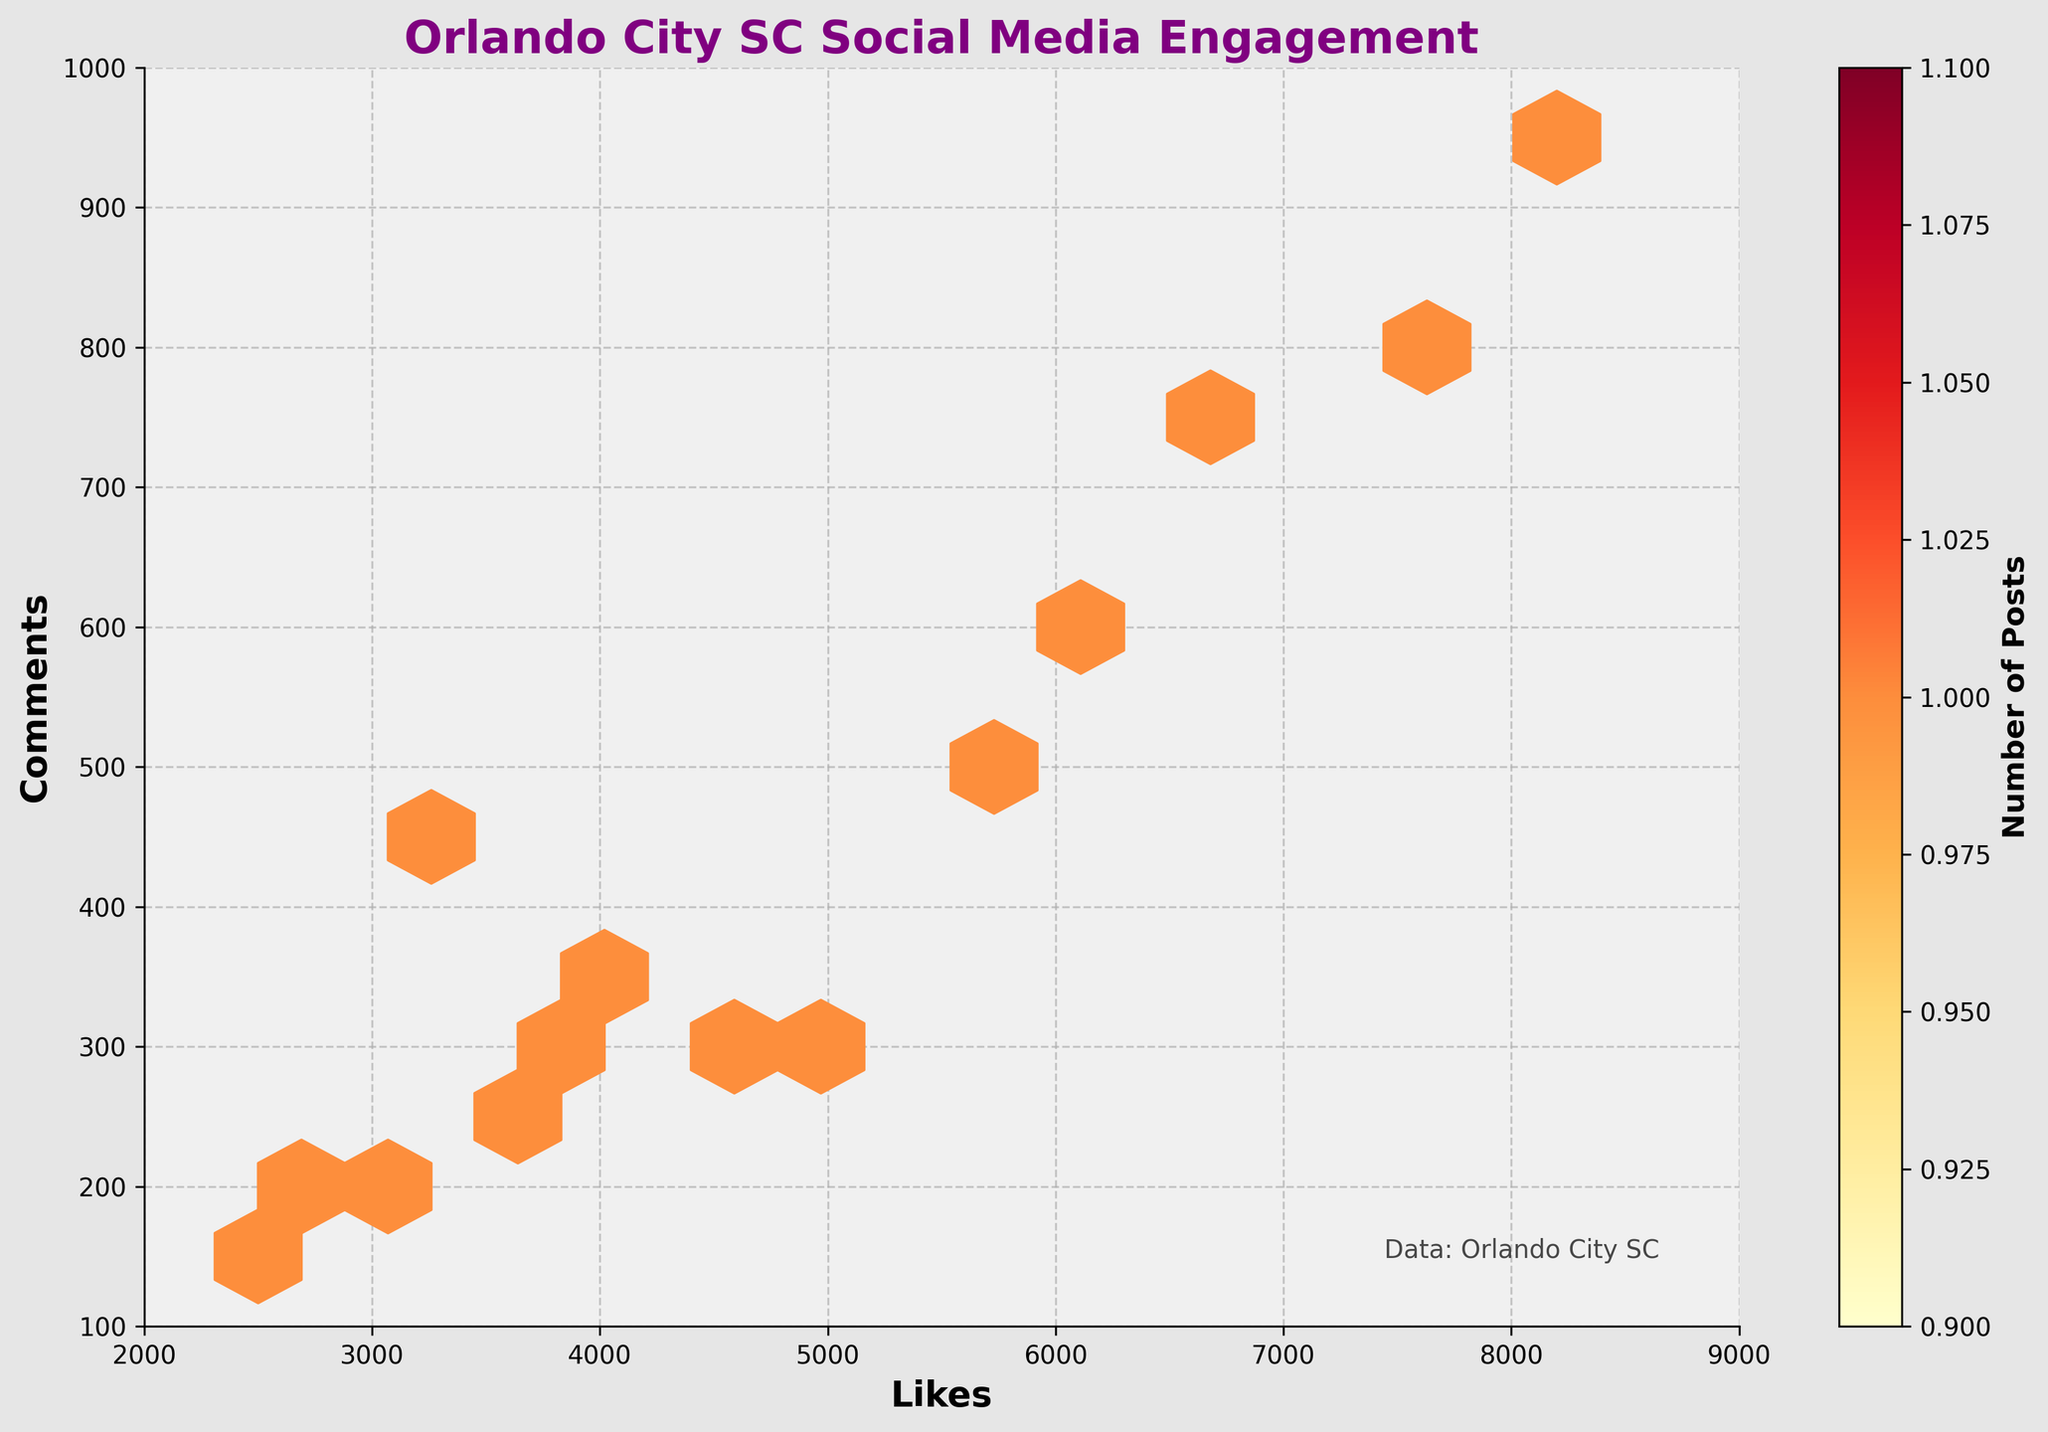what is the title of the plot? The title is located at the top of the plot. It is visually distinct due to its color (purple) and font size.
Answer: Orlando City SC Social Media Engagement What do the x and y axes represent? The x-axis is depicted in the lower part of the plot and represents the number of likes. The y-axis is shown on the left side and represents the number of comments.
Answer: Likes vs Comments What color is predominantly used in the hexbin plot? The color scheme of the hexagons in the plot is shown in shades of yellow, orange, and red. This is indicated by the 'YlOrRd' colormap used, transitioning from lighter to darker shades.
Answer: Yellow to Red Which metric is more intensively shaded in the plot, likes or comments? The density of shading, represented by darker hexagons, indicates higher concentration of data points. Observation shows most shaded regions are closer to higher likes values, suggesting higher intensity.
Answer: Likes How many posts have around 6,000 likes and 600 comments? Focusing on the hexagon near the coordinates (6000, 600), the color intensity and shading helps estimate the number of posts. This position is moderately shaded, suggesting a mid-range number.
Answer: Approx. 1-2 What is the general trend between likes and comments based on the hexbin plot? By observing the distribution and the direction of denser hexagons, one can note the trend that as likes increase, comments also increase. This is indicated by the upward and rightward concentration of hexagons.
Answer: Positive Correlation What can be inferred about posts with more than 8,000 likes? Posts with more than 8,000 likes are positioned on the extreme right side of the plot. The color intensity of the hexagons within this range along with higher comments suggests that these are particularly engaging posts.
Answer: Highly engaging Are there more posts with fewer than 4,000 likes or more than 4,000 likes? By splitting the plot at the 4,000 likes mark and comparing the density of hexagons on each side, it appears there are more posts with likes above this threshold. This is inferred from denser hexagon concentration in the higher likes region.
Answer: More than 4,000 likes Which aspect has more variability, likes or comments? Variability can be gauged by assessing the spread of hexagons along each axis. Observing the plot, the comments range from 100 to 1,000 while likes range from 2,000 to 9,000. The likes have wider variability.
Answer: Likes Do posts with fewer likes tend to have fewer comments? Evaluating the plot, posts with fewer likes (on the left-hand side of the x-axis) do show fewer comments (lower on the y-axis). This pattern confirms fewer likes are accompanied by fewer comments.
Answer: Yes 